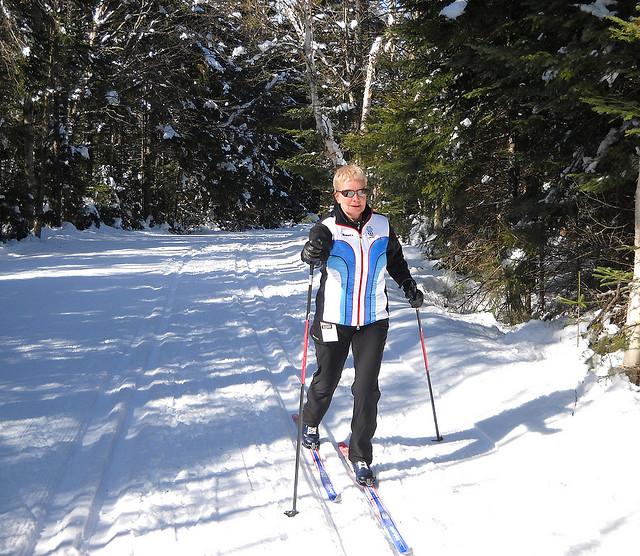What is the woman doing?
Answer briefly. Skiing. What color are the stripes on the lady's jacket?
Write a very short answer. Blue. What sport is this woman doing?
Keep it brief. Skiing. 